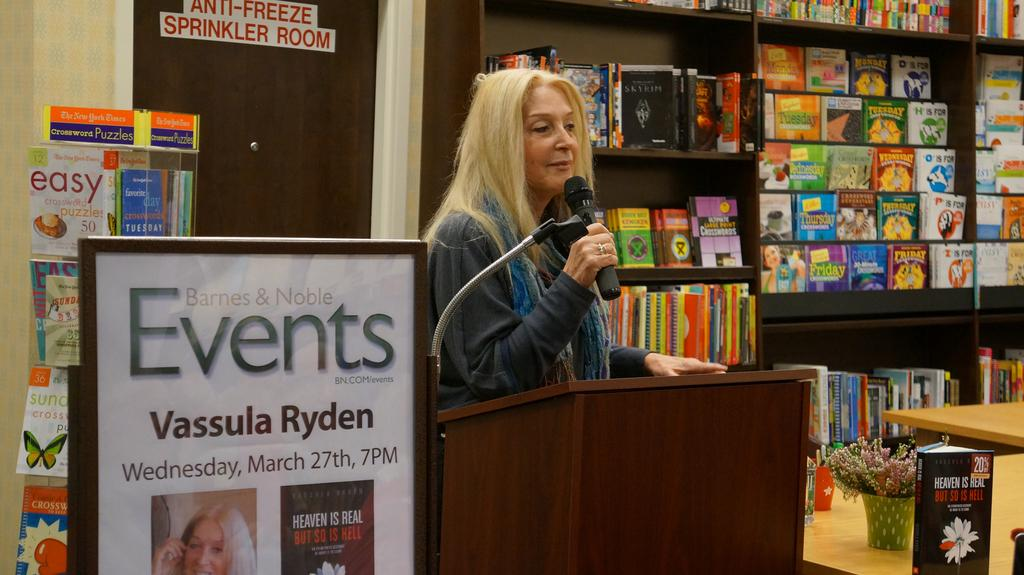<image>
Summarize the visual content of the image. A woman speaking next to a sign that says "Events Vassula Ryden" 